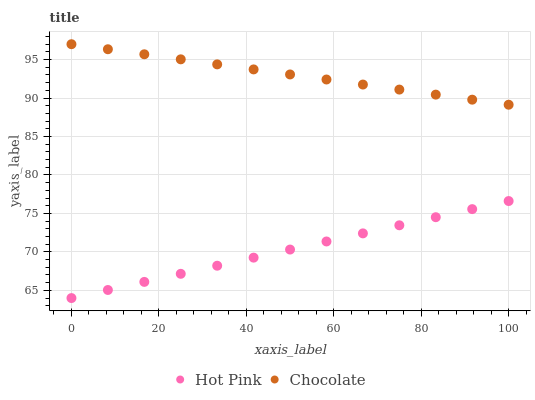Does Hot Pink have the minimum area under the curve?
Answer yes or no. Yes. Does Chocolate have the maximum area under the curve?
Answer yes or no. Yes. Does Chocolate have the minimum area under the curve?
Answer yes or no. No. Is Hot Pink the smoothest?
Answer yes or no. Yes. Is Chocolate the roughest?
Answer yes or no. Yes. Is Chocolate the smoothest?
Answer yes or no. No. Does Hot Pink have the lowest value?
Answer yes or no. Yes. Does Chocolate have the lowest value?
Answer yes or no. No. Does Chocolate have the highest value?
Answer yes or no. Yes. Is Hot Pink less than Chocolate?
Answer yes or no. Yes. Is Chocolate greater than Hot Pink?
Answer yes or no. Yes. Does Hot Pink intersect Chocolate?
Answer yes or no. No. 